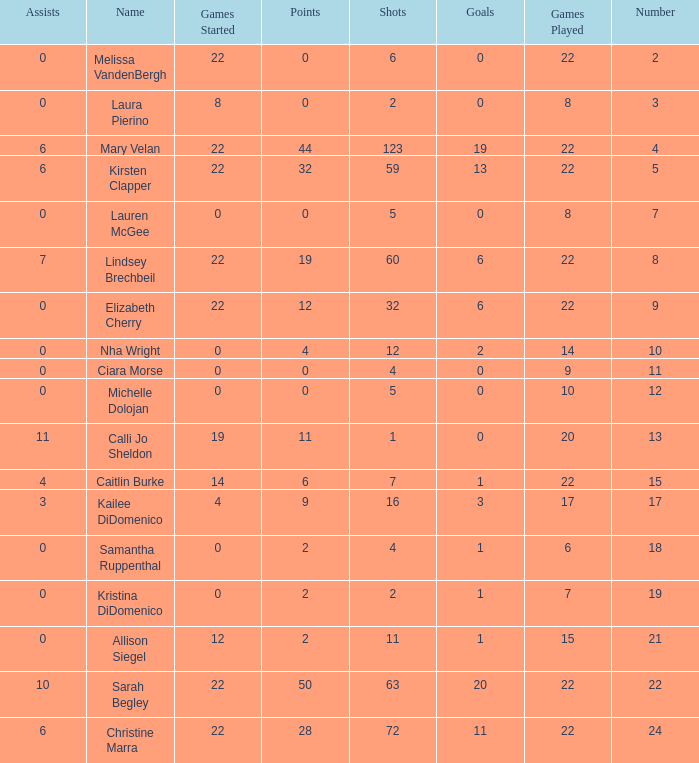How many names are listed for the player with 50 points? 1.0. Could you parse the entire table as a dict? {'header': ['Assists', 'Name', 'Games Started', 'Points', 'Shots', 'Goals', 'Games Played', 'Number'], 'rows': [['0', 'Melissa VandenBergh', '22', '0', '6', '0', '22', '2'], ['0', 'Laura Pierino', '8', '0', '2', '0', '8', '3'], ['6', 'Mary Velan', '22', '44', '123', '19', '22', '4'], ['6', 'Kirsten Clapper', '22', '32', '59', '13', '22', '5'], ['0', 'Lauren McGee', '0', '0', '5', '0', '8', '7'], ['7', 'Lindsey Brechbeil', '22', '19', '60', '6', '22', '8'], ['0', 'Elizabeth Cherry', '22', '12', '32', '6', '22', '9'], ['0', 'Nha Wright', '0', '4', '12', '2', '14', '10'], ['0', 'Ciara Morse', '0', '0', '4', '0', '9', '11'], ['0', 'Michelle Dolojan', '0', '0', '5', '0', '10', '12'], ['11', 'Calli Jo Sheldon', '19', '11', '1', '0', '20', '13'], ['4', 'Caitlin Burke', '14', '6', '7', '1', '22', '15'], ['3', 'Kailee DiDomenico', '4', '9', '16', '3', '17', '17'], ['0', 'Samantha Ruppenthal', '0', '2', '4', '1', '6', '18'], ['0', 'Kristina DiDomenico', '0', '2', '2', '1', '7', '19'], ['0', 'Allison Siegel', '12', '2', '11', '1', '15', '21'], ['10', 'Sarah Begley', '22', '50', '63', '20', '22', '22'], ['6', 'Christine Marra', '22', '28', '72', '11', '22', '24']]} 